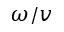<formula> <loc_0><loc_0><loc_500><loc_500>\omega / v</formula> 